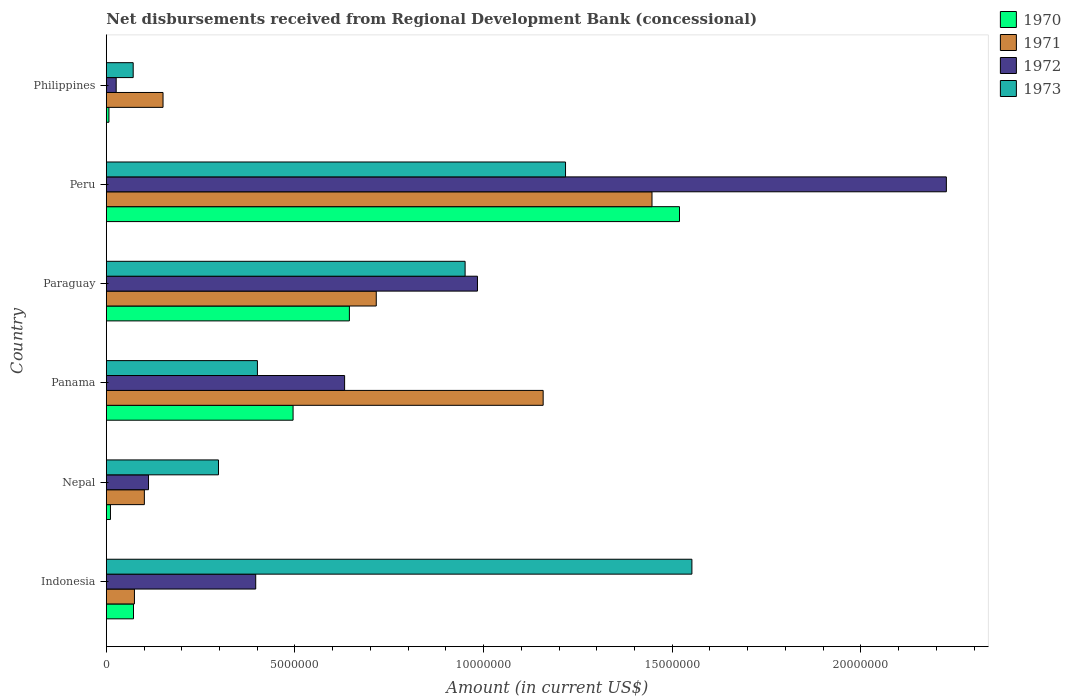How many different coloured bars are there?
Offer a very short reply. 4. Are the number of bars per tick equal to the number of legend labels?
Your answer should be very brief. Yes. Are the number of bars on each tick of the Y-axis equal?
Provide a short and direct response. Yes. In how many cases, is the number of bars for a given country not equal to the number of legend labels?
Make the answer very short. 0. What is the amount of disbursements received from Regional Development Bank in 1971 in Philippines?
Your answer should be compact. 1.50e+06. Across all countries, what is the maximum amount of disbursements received from Regional Development Bank in 1971?
Offer a very short reply. 1.45e+07. Across all countries, what is the minimum amount of disbursements received from Regional Development Bank in 1973?
Offer a terse response. 7.12e+05. What is the total amount of disbursements received from Regional Development Bank in 1973 in the graph?
Give a very brief answer. 4.49e+07. What is the difference between the amount of disbursements received from Regional Development Bank in 1971 in Paraguay and that in Peru?
Offer a terse response. -7.31e+06. What is the difference between the amount of disbursements received from Regional Development Bank in 1973 in Indonesia and the amount of disbursements received from Regional Development Bank in 1972 in Peru?
Your response must be concise. -6.74e+06. What is the average amount of disbursements received from Regional Development Bank in 1973 per country?
Your response must be concise. 7.48e+06. What is the difference between the amount of disbursements received from Regional Development Bank in 1971 and amount of disbursements received from Regional Development Bank in 1972 in Peru?
Keep it short and to the point. -7.80e+06. In how many countries, is the amount of disbursements received from Regional Development Bank in 1971 greater than 1000000 US$?
Give a very brief answer. 5. What is the ratio of the amount of disbursements received from Regional Development Bank in 1973 in Paraguay to that in Peru?
Your answer should be compact. 0.78. Is the amount of disbursements received from Regional Development Bank in 1971 in Indonesia less than that in Panama?
Give a very brief answer. Yes. Is the difference between the amount of disbursements received from Regional Development Bank in 1971 in Indonesia and Panama greater than the difference between the amount of disbursements received from Regional Development Bank in 1972 in Indonesia and Panama?
Your response must be concise. No. What is the difference between the highest and the second highest amount of disbursements received from Regional Development Bank in 1972?
Offer a very short reply. 1.24e+07. What is the difference between the highest and the lowest amount of disbursements received from Regional Development Bank in 1970?
Provide a short and direct response. 1.51e+07. In how many countries, is the amount of disbursements received from Regional Development Bank in 1973 greater than the average amount of disbursements received from Regional Development Bank in 1973 taken over all countries?
Offer a terse response. 3. Is it the case that in every country, the sum of the amount of disbursements received from Regional Development Bank in 1971 and amount of disbursements received from Regional Development Bank in 1972 is greater than the amount of disbursements received from Regional Development Bank in 1973?
Your response must be concise. No. How many bars are there?
Offer a terse response. 24. What is the difference between two consecutive major ticks on the X-axis?
Your answer should be very brief. 5.00e+06. Are the values on the major ticks of X-axis written in scientific E-notation?
Make the answer very short. No. How many legend labels are there?
Your answer should be very brief. 4. What is the title of the graph?
Ensure brevity in your answer.  Net disbursements received from Regional Development Bank (concessional). What is the label or title of the X-axis?
Provide a succinct answer. Amount (in current US$). What is the label or title of the Y-axis?
Your answer should be compact. Country. What is the Amount (in current US$) in 1970 in Indonesia?
Ensure brevity in your answer.  7.20e+05. What is the Amount (in current US$) in 1971 in Indonesia?
Ensure brevity in your answer.  7.45e+05. What is the Amount (in current US$) of 1972 in Indonesia?
Offer a terse response. 3.96e+06. What is the Amount (in current US$) in 1973 in Indonesia?
Provide a succinct answer. 1.55e+07. What is the Amount (in current US$) of 1970 in Nepal?
Provide a succinct answer. 1.09e+05. What is the Amount (in current US$) in 1971 in Nepal?
Your answer should be very brief. 1.01e+06. What is the Amount (in current US$) of 1972 in Nepal?
Make the answer very short. 1.12e+06. What is the Amount (in current US$) of 1973 in Nepal?
Offer a very short reply. 2.97e+06. What is the Amount (in current US$) of 1970 in Panama?
Ensure brevity in your answer.  4.95e+06. What is the Amount (in current US$) in 1971 in Panama?
Make the answer very short. 1.16e+07. What is the Amount (in current US$) in 1972 in Panama?
Your response must be concise. 6.32e+06. What is the Amount (in current US$) of 1973 in Panama?
Your answer should be compact. 4.00e+06. What is the Amount (in current US$) of 1970 in Paraguay?
Offer a very short reply. 6.44e+06. What is the Amount (in current US$) of 1971 in Paraguay?
Your answer should be very brief. 7.16e+06. What is the Amount (in current US$) in 1972 in Paraguay?
Give a very brief answer. 9.84e+06. What is the Amount (in current US$) of 1973 in Paraguay?
Your response must be concise. 9.51e+06. What is the Amount (in current US$) of 1970 in Peru?
Make the answer very short. 1.52e+07. What is the Amount (in current US$) in 1971 in Peru?
Your response must be concise. 1.45e+07. What is the Amount (in current US$) in 1972 in Peru?
Provide a short and direct response. 2.23e+07. What is the Amount (in current US$) of 1973 in Peru?
Make the answer very short. 1.22e+07. What is the Amount (in current US$) in 1970 in Philippines?
Ensure brevity in your answer.  6.90e+04. What is the Amount (in current US$) in 1971 in Philippines?
Your answer should be very brief. 1.50e+06. What is the Amount (in current US$) in 1972 in Philippines?
Your answer should be compact. 2.61e+05. What is the Amount (in current US$) in 1973 in Philippines?
Offer a terse response. 7.12e+05. Across all countries, what is the maximum Amount (in current US$) of 1970?
Give a very brief answer. 1.52e+07. Across all countries, what is the maximum Amount (in current US$) of 1971?
Your response must be concise. 1.45e+07. Across all countries, what is the maximum Amount (in current US$) in 1972?
Provide a succinct answer. 2.23e+07. Across all countries, what is the maximum Amount (in current US$) in 1973?
Give a very brief answer. 1.55e+07. Across all countries, what is the minimum Amount (in current US$) in 1970?
Offer a terse response. 6.90e+04. Across all countries, what is the minimum Amount (in current US$) of 1971?
Your response must be concise. 7.45e+05. Across all countries, what is the minimum Amount (in current US$) in 1972?
Keep it short and to the point. 2.61e+05. Across all countries, what is the minimum Amount (in current US$) of 1973?
Provide a succinct answer. 7.12e+05. What is the total Amount (in current US$) in 1970 in the graph?
Provide a succinct answer. 2.75e+07. What is the total Amount (in current US$) of 1971 in the graph?
Offer a terse response. 3.65e+07. What is the total Amount (in current US$) of 1972 in the graph?
Offer a terse response. 4.38e+07. What is the total Amount (in current US$) of 1973 in the graph?
Your answer should be very brief. 4.49e+07. What is the difference between the Amount (in current US$) in 1970 in Indonesia and that in Nepal?
Your response must be concise. 6.11e+05. What is the difference between the Amount (in current US$) in 1971 in Indonesia and that in Nepal?
Your response must be concise. -2.63e+05. What is the difference between the Amount (in current US$) of 1972 in Indonesia and that in Nepal?
Ensure brevity in your answer.  2.84e+06. What is the difference between the Amount (in current US$) in 1973 in Indonesia and that in Nepal?
Your answer should be very brief. 1.25e+07. What is the difference between the Amount (in current US$) of 1970 in Indonesia and that in Panama?
Ensure brevity in your answer.  -4.23e+06. What is the difference between the Amount (in current US$) in 1971 in Indonesia and that in Panama?
Your answer should be compact. -1.08e+07. What is the difference between the Amount (in current US$) in 1972 in Indonesia and that in Panama?
Give a very brief answer. -2.36e+06. What is the difference between the Amount (in current US$) in 1973 in Indonesia and that in Panama?
Make the answer very short. 1.15e+07. What is the difference between the Amount (in current US$) in 1970 in Indonesia and that in Paraguay?
Provide a short and direct response. -5.72e+06. What is the difference between the Amount (in current US$) of 1971 in Indonesia and that in Paraguay?
Provide a short and direct response. -6.41e+06. What is the difference between the Amount (in current US$) of 1972 in Indonesia and that in Paraguay?
Your answer should be very brief. -5.88e+06. What is the difference between the Amount (in current US$) of 1973 in Indonesia and that in Paraguay?
Give a very brief answer. 6.01e+06. What is the difference between the Amount (in current US$) in 1970 in Indonesia and that in Peru?
Make the answer very short. -1.45e+07. What is the difference between the Amount (in current US$) of 1971 in Indonesia and that in Peru?
Ensure brevity in your answer.  -1.37e+07. What is the difference between the Amount (in current US$) of 1972 in Indonesia and that in Peru?
Offer a terse response. -1.83e+07. What is the difference between the Amount (in current US$) of 1973 in Indonesia and that in Peru?
Provide a short and direct response. 3.35e+06. What is the difference between the Amount (in current US$) in 1970 in Indonesia and that in Philippines?
Your response must be concise. 6.51e+05. What is the difference between the Amount (in current US$) in 1971 in Indonesia and that in Philippines?
Ensure brevity in your answer.  -7.58e+05. What is the difference between the Amount (in current US$) in 1972 in Indonesia and that in Philippines?
Give a very brief answer. 3.70e+06. What is the difference between the Amount (in current US$) of 1973 in Indonesia and that in Philippines?
Offer a terse response. 1.48e+07. What is the difference between the Amount (in current US$) in 1970 in Nepal and that in Panama?
Your answer should be compact. -4.84e+06. What is the difference between the Amount (in current US$) in 1971 in Nepal and that in Panama?
Give a very brief answer. -1.06e+07. What is the difference between the Amount (in current US$) of 1972 in Nepal and that in Panama?
Your answer should be very brief. -5.20e+06. What is the difference between the Amount (in current US$) in 1973 in Nepal and that in Panama?
Make the answer very short. -1.03e+06. What is the difference between the Amount (in current US$) in 1970 in Nepal and that in Paraguay?
Provide a succinct answer. -6.33e+06. What is the difference between the Amount (in current US$) of 1971 in Nepal and that in Paraguay?
Your response must be concise. -6.15e+06. What is the difference between the Amount (in current US$) in 1972 in Nepal and that in Paraguay?
Your answer should be very brief. -8.72e+06. What is the difference between the Amount (in current US$) of 1973 in Nepal and that in Paraguay?
Your answer should be compact. -6.54e+06. What is the difference between the Amount (in current US$) in 1970 in Nepal and that in Peru?
Your answer should be compact. -1.51e+07. What is the difference between the Amount (in current US$) in 1971 in Nepal and that in Peru?
Ensure brevity in your answer.  -1.35e+07. What is the difference between the Amount (in current US$) in 1972 in Nepal and that in Peru?
Offer a very short reply. -2.11e+07. What is the difference between the Amount (in current US$) of 1973 in Nepal and that in Peru?
Provide a short and direct response. -9.20e+06. What is the difference between the Amount (in current US$) in 1971 in Nepal and that in Philippines?
Provide a succinct answer. -4.95e+05. What is the difference between the Amount (in current US$) of 1972 in Nepal and that in Philippines?
Your answer should be compact. 8.57e+05. What is the difference between the Amount (in current US$) of 1973 in Nepal and that in Philippines?
Ensure brevity in your answer.  2.26e+06. What is the difference between the Amount (in current US$) in 1970 in Panama and that in Paraguay?
Offer a terse response. -1.49e+06. What is the difference between the Amount (in current US$) of 1971 in Panama and that in Paraguay?
Your answer should be very brief. 4.42e+06. What is the difference between the Amount (in current US$) in 1972 in Panama and that in Paraguay?
Offer a terse response. -3.52e+06. What is the difference between the Amount (in current US$) in 1973 in Panama and that in Paraguay?
Provide a short and direct response. -5.50e+06. What is the difference between the Amount (in current US$) of 1970 in Panama and that in Peru?
Your response must be concise. -1.02e+07. What is the difference between the Amount (in current US$) of 1971 in Panama and that in Peru?
Offer a very short reply. -2.88e+06. What is the difference between the Amount (in current US$) in 1972 in Panama and that in Peru?
Ensure brevity in your answer.  -1.60e+07. What is the difference between the Amount (in current US$) of 1973 in Panama and that in Peru?
Make the answer very short. -8.17e+06. What is the difference between the Amount (in current US$) in 1970 in Panama and that in Philippines?
Offer a very short reply. 4.88e+06. What is the difference between the Amount (in current US$) in 1971 in Panama and that in Philippines?
Keep it short and to the point. 1.01e+07. What is the difference between the Amount (in current US$) in 1972 in Panama and that in Philippines?
Your answer should be compact. 6.06e+06. What is the difference between the Amount (in current US$) of 1973 in Panama and that in Philippines?
Your response must be concise. 3.29e+06. What is the difference between the Amount (in current US$) in 1970 in Paraguay and that in Peru?
Your response must be concise. -8.75e+06. What is the difference between the Amount (in current US$) in 1971 in Paraguay and that in Peru?
Provide a succinct answer. -7.31e+06. What is the difference between the Amount (in current US$) in 1972 in Paraguay and that in Peru?
Provide a succinct answer. -1.24e+07. What is the difference between the Amount (in current US$) in 1973 in Paraguay and that in Peru?
Keep it short and to the point. -2.66e+06. What is the difference between the Amount (in current US$) of 1970 in Paraguay and that in Philippines?
Your answer should be very brief. 6.37e+06. What is the difference between the Amount (in current US$) of 1971 in Paraguay and that in Philippines?
Offer a terse response. 5.65e+06. What is the difference between the Amount (in current US$) in 1972 in Paraguay and that in Philippines?
Your answer should be compact. 9.58e+06. What is the difference between the Amount (in current US$) in 1973 in Paraguay and that in Philippines?
Provide a succinct answer. 8.80e+06. What is the difference between the Amount (in current US$) of 1970 in Peru and that in Philippines?
Provide a succinct answer. 1.51e+07. What is the difference between the Amount (in current US$) of 1971 in Peru and that in Philippines?
Give a very brief answer. 1.30e+07. What is the difference between the Amount (in current US$) in 1972 in Peru and that in Philippines?
Your answer should be compact. 2.20e+07. What is the difference between the Amount (in current US$) of 1973 in Peru and that in Philippines?
Your answer should be compact. 1.15e+07. What is the difference between the Amount (in current US$) of 1970 in Indonesia and the Amount (in current US$) of 1971 in Nepal?
Ensure brevity in your answer.  -2.88e+05. What is the difference between the Amount (in current US$) of 1970 in Indonesia and the Amount (in current US$) of 1972 in Nepal?
Your answer should be compact. -3.98e+05. What is the difference between the Amount (in current US$) of 1970 in Indonesia and the Amount (in current US$) of 1973 in Nepal?
Give a very brief answer. -2.25e+06. What is the difference between the Amount (in current US$) in 1971 in Indonesia and the Amount (in current US$) in 1972 in Nepal?
Provide a short and direct response. -3.73e+05. What is the difference between the Amount (in current US$) of 1971 in Indonesia and the Amount (in current US$) of 1973 in Nepal?
Your response must be concise. -2.23e+06. What is the difference between the Amount (in current US$) of 1972 in Indonesia and the Amount (in current US$) of 1973 in Nepal?
Make the answer very short. 9.87e+05. What is the difference between the Amount (in current US$) in 1970 in Indonesia and the Amount (in current US$) in 1971 in Panama?
Your answer should be very brief. -1.09e+07. What is the difference between the Amount (in current US$) of 1970 in Indonesia and the Amount (in current US$) of 1972 in Panama?
Make the answer very short. -5.60e+06. What is the difference between the Amount (in current US$) of 1970 in Indonesia and the Amount (in current US$) of 1973 in Panama?
Offer a terse response. -3.28e+06. What is the difference between the Amount (in current US$) of 1971 in Indonesia and the Amount (in current US$) of 1972 in Panama?
Make the answer very short. -5.57e+06. What is the difference between the Amount (in current US$) of 1971 in Indonesia and the Amount (in current US$) of 1973 in Panama?
Your answer should be very brief. -3.26e+06. What is the difference between the Amount (in current US$) of 1972 in Indonesia and the Amount (in current US$) of 1973 in Panama?
Provide a short and direct response. -4.50e+04. What is the difference between the Amount (in current US$) in 1970 in Indonesia and the Amount (in current US$) in 1971 in Paraguay?
Offer a terse response. -6.44e+06. What is the difference between the Amount (in current US$) in 1970 in Indonesia and the Amount (in current US$) in 1972 in Paraguay?
Offer a terse response. -9.12e+06. What is the difference between the Amount (in current US$) in 1970 in Indonesia and the Amount (in current US$) in 1973 in Paraguay?
Your answer should be compact. -8.79e+06. What is the difference between the Amount (in current US$) in 1971 in Indonesia and the Amount (in current US$) in 1972 in Paraguay?
Keep it short and to the point. -9.09e+06. What is the difference between the Amount (in current US$) of 1971 in Indonesia and the Amount (in current US$) of 1973 in Paraguay?
Make the answer very short. -8.76e+06. What is the difference between the Amount (in current US$) in 1972 in Indonesia and the Amount (in current US$) in 1973 in Paraguay?
Make the answer very short. -5.55e+06. What is the difference between the Amount (in current US$) of 1970 in Indonesia and the Amount (in current US$) of 1971 in Peru?
Offer a very short reply. -1.37e+07. What is the difference between the Amount (in current US$) in 1970 in Indonesia and the Amount (in current US$) in 1972 in Peru?
Make the answer very short. -2.15e+07. What is the difference between the Amount (in current US$) of 1970 in Indonesia and the Amount (in current US$) of 1973 in Peru?
Your response must be concise. -1.15e+07. What is the difference between the Amount (in current US$) of 1971 in Indonesia and the Amount (in current US$) of 1972 in Peru?
Your answer should be very brief. -2.15e+07. What is the difference between the Amount (in current US$) of 1971 in Indonesia and the Amount (in current US$) of 1973 in Peru?
Your response must be concise. -1.14e+07. What is the difference between the Amount (in current US$) of 1972 in Indonesia and the Amount (in current US$) of 1973 in Peru?
Offer a very short reply. -8.21e+06. What is the difference between the Amount (in current US$) of 1970 in Indonesia and the Amount (in current US$) of 1971 in Philippines?
Keep it short and to the point. -7.83e+05. What is the difference between the Amount (in current US$) of 1970 in Indonesia and the Amount (in current US$) of 1972 in Philippines?
Offer a terse response. 4.59e+05. What is the difference between the Amount (in current US$) of 1970 in Indonesia and the Amount (in current US$) of 1973 in Philippines?
Your answer should be compact. 8000. What is the difference between the Amount (in current US$) of 1971 in Indonesia and the Amount (in current US$) of 1972 in Philippines?
Keep it short and to the point. 4.84e+05. What is the difference between the Amount (in current US$) in 1971 in Indonesia and the Amount (in current US$) in 1973 in Philippines?
Your answer should be compact. 3.30e+04. What is the difference between the Amount (in current US$) of 1972 in Indonesia and the Amount (in current US$) of 1973 in Philippines?
Provide a succinct answer. 3.25e+06. What is the difference between the Amount (in current US$) in 1970 in Nepal and the Amount (in current US$) in 1971 in Panama?
Make the answer very short. -1.15e+07. What is the difference between the Amount (in current US$) in 1970 in Nepal and the Amount (in current US$) in 1972 in Panama?
Ensure brevity in your answer.  -6.21e+06. What is the difference between the Amount (in current US$) of 1970 in Nepal and the Amount (in current US$) of 1973 in Panama?
Give a very brief answer. -3.90e+06. What is the difference between the Amount (in current US$) of 1971 in Nepal and the Amount (in current US$) of 1972 in Panama?
Keep it short and to the point. -5.31e+06. What is the difference between the Amount (in current US$) of 1971 in Nepal and the Amount (in current US$) of 1973 in Panama?
Provide a short and direct response. -3.00e+06. What is the difference between the Amount (in current US$) in 1972 in Nepal and the Amount (in current US$) in 1973 in Panama?
Offer a very short reply. -2.89e+06. What is the difference between the Amount (in current US$) in 1970 in Nepal and the Amount (in current US$) in 1971 in Paraguay?
Give a very brief answer. -7.05e+06. What is the difference between the Amount (in current US$) of 1970 in Nepal and the Amount (in current US$) of 1972 in Paraguay?
Ensure brevity in your answer.  -9.73e+06. What is the difference between the Amount (in current US$) of 1970 in Nepal and the Amount (in current US$) of 1973 in Paraguay?
Offer a terse response. -9.40e+06. What is the difference between the Amount (in current US$) in 1971 in Nepal and the Amount (in current US$) in 1972 in Paraguay?
Offer a very short reply. -8.83e+06. What is the difference between the Amount (in current US$) of 1971 in Nepal and the Amount (in current US$) of 1973 in Paraguay?
Your answer should be very brief. -8.50e+06. What is the difference between the Amount (in current US$) in 1972 in Nepal and the Amount (in current US$) in 1973 in Paraguay?
Ensure brevity in your answer.  -8.39e+06. What is the difference between the Amount (in current US$) of 1970 in Nepal and the Amount (in current US$) of 1971 in Peru?
Your answer should be compact. -1.44e+07. What is the difference between the Amount (in current US$) in 1970 in Nepal and the Amount (in current US$) in 1972 in Peru?
Offer a terse response. -2.22e+07. What is the difference between the Amount (in current US$) in 1970 in Nepal and the Amount (in current US$) in 1973 in Peru?
Ensure brevity in your answer.  -1.21e+07. What is the difference between the Amount (in current US$) of 1971 in Nepal and the Amount (in current US$) of 1972 in Peru?
Provide a short and direct response. -2.13e+07. What is the difference between the Amount (in current US$) in 1971 in Nepal and the Amount (in current US$) in 1973 in Peru?
Your response must be concise. -1.12e+07. What is the difference between the Amount (in current US$) of 1972 in Nepal and the Amount (in current US$) of 1973 in Peru?
Give a very brief answer. -1.11e+07. What is the difference between the Amount (in current US$) in 1970 in Nepal and the Amount (in current US$) in 1971 in Philippines?
Offer a terse response. -1.39e+06. What is the difference between the Amount (in current US$) of 1970 in Nepal and the Amount (in current US$) of 1972 in Philippines?
Make the answer very short. -1.52e+05. What is the difference between the Amount (in current US$) of 1970 in Nepal and the Amount (in current US$) of 1973 in Philippines?
Provide a short and direct response. -6.03e+05. What is the difference between the Amount (in current US$) of 1971 in Nepal and the Amount (in current US$) of 1972 in Philippines?
Offer a terse response. 7.47e+05. What is the difference between the Amount (in current US$) of 1971 in Nepal and the Amount (in current US$) of 1973 in Philippines?
Make the answer very short. 2.96e+05. What is the difference between the Amount (in current US$) of 1972 in Nepal and the Amount (in current US$) of 1973 in Philippines?
Give a very brief answer. 4.06e+05. What is the difference between the Amount (in current US$) in 1970 in Panama and the Amount (in current US$) in 1971 in Paraguay?
Offer a terse response. -2.20e+06. What is the difference between the Amount (in current US$) of 1970 in Panama and the Amount (in current US$) of 1972 in Paraguay?
Provide a succinct answer. -4.89e+06. What is the difference between the Amount (in current US$) in 1970 in Panama and the Amount (in current US$) in 1973 in Paraguay?
Provide a succinct answer. -4.56e+06. What is the difference between the Amount (in current US$) in 1971 in Panama and the Amount (in current US$) in 1972 in Paraguay?
Give a very brief answer. 1.74e+06. What is the difference between the Amount (in current US$) of 1971 in Panama and the Amount (in current US$) of 1973 in Paraguay?
Give a very brief answer. 2.07e+06. What is the difference between the Amount (in current US$) of 1972 in Panama and the Amount (in current US$) of 1973 in Paraguay?
Give a very brief answer. -3.19e+06. What is the difference between the Amount (in current US$) in 1970 in Panama and the Amount (in current US$) in 1971 in Peru?
Keep it short and to the point. -9.51e+06. What is the difference between the Amount (in current US$) of 1970 in Panama and the Amount (in current US$) of 1972 in Peru?
Offer a very short reply. -1.73e+07. What is the difference between the Amount (in current US$) of 1970 in Panama and the Amount (in current US$) of 1973 in Peru?
Provide a short and direct response. -7.22e+06. What is the difference between the Amount (in current US$) in 1971 in Panama and the Amount (in current US$) in 1972 in Peru?
Make the answer very short. -1.07e+07. What is the difference between the Amount (in current US$) of 1971 in Panama and the Amount (in current US$) of 1973 in Peru?
Your answer should be very brief. -5.93e+05. What is the difference between the Amount (in current US$) in 1972 in Panama and the Amount (in current US$) in 1973 in Peru?
Offer a very short reply. -5.86e+06. What is the difference between the Amount (in current US$) of 1970 in Panama and the Amount (in current US$) of 1971 in Philippines?
Provide a succinct answer. 3.45e+06. What is the difference between the Amount (in current US$) in 1970 in Panama and the Amount (in current US$) in 1972 in Philippines?
Your answer should be very brief. 4.69e+06. What is the difference between the Amount (in current US$) of 1970 in Panama and the Amount (in current US$) of 1973 in Philippines?
Give a very brief answer. 4.24e+06. What is the difference between the Amount (in current US$) of 1971 in Panama and the Amount (in current US$) of 1972 in Philippines?
Your answer should be very brief. 1.13e+07. What is the difference between the Amount (in current US$) in 1971 in Panama and the Amount (in current US$) in 1973 in Philippines?
Ensure brevity in your answer.  1.09e+07. What is the difference between the Amount (in current US$) in 1972 in Panama and the Amount (in current US$) in 1973 in Philippines?
Offer a very short reply. 5.60e+06. What is the difference between the Amount (in current US$) of 1970 in Paraguay and the Amount (in current US$) of 1971 in Peru?
Offer a very short reply. -8.02e+06. What is the difference between the Amount (in current US$) in 1970 in Paraguay and the Amount (in current US$) in 1972 in Peru?
Offer a very short reply. -1.58e+07. What is the difference between the Amount (in current US$) in 1970 in Paraguay and the Amount (in current US$) in 1973 in Peru?
Your response must be concise. -5.73e+06. What is the difference between the Amount (in current US$) in 1971 in Paraguay and the Amount (in current US$) in 1972 in Peru?
Make the answer very short. -1.51e+07. What is the difference between the Amount (in current US$) of 1971 in Paraguay and the Amount (in current US$) of 1973 in Peru?
Your answer should be very brief. -5.02e+06. What is the difference between the Amount (in current US$) in 1972 in Paraguay and the Amount (in current US$) in 1973 in Peru?
Offer a very short reply. -2.33e+06. What is the difference between the Amount (in current US$) in 1970 in Paraguay and the Amount (in current US$) in 1971 in Philippines?
Ensure brevity in your answer.  4.94e+06. What is the difference between the Amount (in current US$) of 1970 in Paraguay and the Amount (in current US$) of 1972 in Philippines?
Give a very brief answer. 6.18e+06. What is the difference between the Amount (in current US$) of 1970 in Paraguay and the Amount (in current US$) of 1973 in Philippines?
Your answer should be very brief. 5.73e+06. What is the difference between the Amount (in current US$) in 1971 in Paraguay and the Amount (in current US$) in 1972 in Philippines?
Offer a terse response. 6.89e+06. What is the difference between the Amount (in current US$) in 1971 in Paraguay and the Amount (in current US$) in 1973 in Philippines?
Your response must be concise. 6.44e+06. What is the difference between the Amount (in current US$) of 1972 in Paraguay and the Amount (in current US$) of 1973 in Philippines?
Offer a very short reply. 9.13e+06. What is the difference between the Amount (in current US$) of 1970 in Peru and the Amount (in current US$) of 1971 in Philippines?
Your answer should be very brief. 1.37e+07. What is the difference between the Amount (in current US$) in 1970 in Peru and the Amount (in current US$) in 1972 in Philippines?
Your answer should be very brief. 1.49e+07. What is the difference between the Amount (in current US$) of 1970 in Peru and the Amount (in current US$) of 1973 in Philippines?
Your answer should be very brief. 1.45e+07. What is the difference between the Amount (in current US$) in 1971 in Peru and the Amount (in current US$) in 1972 in Philippines?
Your answer should be compact. 1.42e+07. What is the difference between the Amount (in current US$) of 1971 in Peru and the Amount (in current US$) of 1973 in Philippines?
Offer a very short reply. 1.38e+07. What is the difference between the Amount (in current US$) in 1972 in Peru and the Amount (in current US$) in 1973 in Philippines?
Your answer should be very brief. 2.16e+07. What is the average Amount (in current US$) of 1970 per country?
Your response must be concise. 4.58e+06. What is the average Amount (in current US$) in 1971 per country?
Ensure brevity in your answer.  6.08e+06. What is the average Amount (in current US$) of 1972 per country?
Ensure brevity in your answer.  7.29e+06. What is the average Amount (in current US$) in 1973 per country?
Your answer should be compact. 7.48e+06. What is the difference between the Amount (in current US$) of 1970 and Amount (in current US$) of 1971 in Indonesia?
Your response must be concise. -2.50e+04. What is the difference between the Amount (in current US$) in 1970 and Amount (in current US$) in 1972 in Indonesia?
Give a very brief answer. -3.24e+06. What is the difference between the Amount (in current US$) of 1970 and Amount (in current US$) of 1973 in Indonesia?
Keep it short and to the point. -1.48e+07. What is the difference between the Amount (in current US$) in 1971 and Amount (in current US$) in 1972 in Indonesia?
Your response must be concise. -3.22e+06. What is the difference between the Amount (in current US$) in 1971 and Amount (in current US$) in 1973 in Indonesia?
Provide a succinct answer. -1.48e+07. What is the difference between the Amount (in current US$) in 1972 and Amount (in current US$) in 1973 in Indonesia?
Make the answer very short. -1.16e+07. What is the difference between the Amount (in current US$) of 1970 and Amount (in current US$) of 1971 in Nepal?
Your answer should be very brief. -8.99e+05. What is the difference between the Amount (in current US$) in 1970 and Amount (in current US$) in 1972 in Nepal?
Ensure brevity in your answer.  -1.01e+06. What is the difference between the Amount (in current US$) in 1970 and Amount (in current US$) in 1973 in Nepal?
Provide a short and direct response. -2.86e+06. What is the difference between the Amount (in current US$) of 1971 and Amount (in current US$) of 1973 in Nepal?
Your answer should be very brief. -1.96e+06. What is the difference between the Amount (in current US$) in 1972 and Amount (in current US$) in 1973 in Nepal?
Your answer should be compact. -1.86e+06. What is the difference between the Amount (in current US$) in 1970 and Amount (in current US$) in 1971 in Panama?
Provide a short and direct response. -6.63e+06. What is the difference between the Amount (in current US$) in 1970 and Amount (in current US$) in 1972 in Panama?
Your answer should be very brief. -1.37e+06. What is the difference between the Amount (in current US$) in 1970 and Amount (in current US$) in 1973 in Panama?
Provide a succinct answer. 9.45e+05. What is the difference between the Amount (in current US$) of 1971 and Amount (in current US$) of 1972 in Panama?
Make the answer very short. 5.26e+06. What is the difference between the Amount (in current US$) of 1971 and Amount (in current US$) of 1973 in Panama?
Provide a succinct answer. 7.57e+06. What is the difference between the Amount (in current US$) in 1972 and Amount (in current US$) in 1973 in Panama?
Give a very brief answer. 2.31e+06. What is the difference between the Amount (in current US$) in 1970 and Amount (in current US$) in 1971 in Paraguay?
Your response must be concise. -7.12e+05. What is the difference between the Amount (in current US$) of 1970 and Amount (in current US$) of 1972 in Paraguay?
Offer a terse response. -3.40e+06. What is the difference between the Amount (in current US$) of 1970 and Amount (in current US$) of 1973 in Paraguay?
Provide a short and direct response. -3.07e+06. What is the difference between the Amount (in current US$) in 1971 and Amount (in current US$) in 1972 in Paraguay?
Give a very brief answer. -2.68e+06. What is the difference between the Amount (in current US$) of 1971 and Amount (in current US$) of 1973 in Paraguay?
Your response must be concise. -2.36e+06. What is the difference between the Amount (in current US$) in 1972 and Amount (in current US$) in 1973 in Paraguay?
Provide a succinct answer. 3.28e+05. What is the difference between the Amount (in current US$) in 1970 and Amount (in current US$) in 1971 in Peru?
Offer a terse response. 7.29e+05. What is the difference between the Amount (in current US$) of 1970 and Amount (in current US$) of 1972 in Peru?
Your answer should be compact. -7.07e+06. What is the difference between the Amount (in current US$) in 1970 and Amount (in current US$) in 1973 in Peru?
Provide a succinct answer. 3.02e+06. What is the difference between the Amount (in current US$) of 1971 and Amount (in current US$) of 1972 in Peru?
Offer a terse response. -7.80e+06. What is the difference between the Amount (in current US$) in 1971 and Amount (in current US$) in 1973 in Peru?
Offer a terse response. 2.29e+06. What is the difference between the Amount (in current US$) of 1972 and Amount (in current US$) of 1973 in Peru?
Give a very brief answer. 1.01e+07. What is the difference between the Amount (in current US$) in 1970 and Amount (in current US$) in 1971 in Philippines?
Offer a terse response. -1.43e+06. What is the difference between the Amount (in current US$) of 1970 and Amount (in current US$) of 1972 in Philippines?
Your answer should be compact. -1.92e+05. What is the difference between the Amount (in current US$) in 1970 and Amount (in current US$) in 1973 in Philippines?
Provide a succinct answer. -6.43e+05. What is the difference between the Amount (in current US$) of 1971 and Amount (in current US$) of 1972 in Philippines?
Keep it short and to the point. 1.24e+06. What is the difference between the Amount (in current US$) in 1971 and Amount (in current US$) in 1973 in Philippines?
Make the answer very short. 7.91e+05. What is the difference between the Amount (in current US$) in 1972 and Amount (in current US$) in 1973 in Philippines?
Keep it short and to the point. -4.51e+05. What is the ratio of the Amount (in current US$) in 1970 in Indonesia to that in Nepal?
Your response must be concise. 6.61. What is the ratio of the Amount (in current US$) in 1971 in Indonesia to that in Nepal?
Ensure brevity in your answer.  0.74. What is the ratio of the Amount (in current US$) in 1972 in Indonesia to that in Nepal?
Your answer should be compact. 3.54. What is the ratio of the Amount (in current US$) of 1973 in Indonesia to that in Nepal?
Your response must be concise. 5.22. What is the ratio of the Amount (in current US$) in 1970 in Indonesia to that in Panama?
Keep it short and to the point. 0.15. What is the ratio of the Amount (in current US$) in 1971 in Indonesia to that in Panama?
Give a very brief answer. 0.06. What is the ratio of the Amount (in current US$) in 1972 in Indonesia to that in Panama?
Offer a terse response. 0.63. What is the ratio of the Amount (in current US$) in 1973 in Indonesia to that in Panama?
Give a very brief answer. 3.88. What is the ratio of the Amount (in current US$) of 1970 in Indonesia to that in Paraguay?
Your answer should be very brief. 0.11. What is the ratio of the Amount (in current US$) of 1971 in Indonesia to that in Paraguay?
Keep it short and to the point. 0.1. What is the ratio of the Amount (in current US$) in 1972 in Indonesia to that in Paraguay?
Offer a terse response. 0.4. What is the ratio of the Amount (in current US$) of 1973 in Indonesia to that in Paraguay?
Ensure brevity in your answer.  1.63. What is the ratio of the Amount (in current US$) in 1970 in Indonesia to that in Peru?
Give a very brief answer. 0.05. What is the ratio of the Amount (in current US$) in 1971 in Indonesia to that in Peru?
Provide a succinct answer. 0.05. What is the ratio of the Amount (in current US$) of 1972 in Indonesia to that in Peru?
Ensure brevity in your answer.  0.18. What is the ratio of the Amount (in current US$) in 1973 in Indonesia to that in Peru?
Your answer should be very brief. 1.28. What is the ratio of the Amount (in current US$) of 1970 in Indonesia to that in Philippines?
Your response must be concise. 10.43. What is the ratio of the Amount (in current US$) in 1971 in Indonesia to that in Philippines?
Keep it short and to the point. 0.5. What is the ratio of the Amount (in current US$) of 1972 in Indonesia to that in Philippines?
Ensure brevity in your answer.  15.17. What is the ratio of the Amount (in current US$) of 1973 in Indonesia to that in Philippines?
Your answer should be very brief. 21.8. What is the ratio of the Amount (in current US$) of 1970 in Nepal to that in Panama?
Provide a succinct answer. 0.02. What is the ratio of the Amount (in current US$) of 1971 in Nepal to that in Panama?
Ensure brevity in your answer.  0.09. What is the ratio of the Amount (in current US$) of 1972 in Nepal to that in Panama?
Offer a terse response. 0.18. What is the ratio of the Amount (in current US$) of 1973 in Nepal to that in Panama?
Your response must be concise. 0.74. What is the ratio of the Amount (in current US$) in 1970 in Nepal to that in Paraguay?
Ensure brevity in your answer.  0.02. What is the ratio of the Amount (in current US$) in 1971 in Nepal to that in Paraguay?
Keep it short and to the point. 0.14. What is the ratio of the Amount (in current US$) of 1972 in Nepal to that in Paraguay?
Make the answer very short. 0.11. What is the ratio of the Amount (in current US$) of 1973 in Nepal to that in Paraguay?
Ensure brevity in your answer.  0.31. What is the ratio of the Amount (in current US$) of 1970 in Nepal to that in Peru?
Keep it short and to the point. 0.01. What is the ratio of the Amount (in current US$) of 1971 in Nepal to that in Peru?
Keep it short and to the point. 0.07. What is the ratio of the Amount (in current US$) of 1972 in Nepal to that in Peru?
Your answer should be very brief. 0.05. What is the ratio of the Amount (in current US$) of 1973 in Nepal to that in Peru?
Ensure brevity in your answer.  0.24. What is the ratio of the Amount (in current US$) of 1970 in Nepal to that in Philippines?
Give a very brief answer. 1.58. What is the ratio of the Amount (in current US$) in 1971 in Nepal to that in Philippines?
Provide a succinct answer. 0.67. What is the ratio of the Amount (in current US$) of 1972 in Nepal to that in Philippines?
Offer a terse response. 4.28. What is the ratio of the Amount (in current US$) of 1973 in Nepal to that in Philippines?
Offer a very short reply. 4.18. What is the ratio of the Amount (in current US$) of 1970 in Panama to that in Paraguay?
Provide a succinct answer. 0.77. What is the ratio of the Amount (in current US$) of 1971 in Panama to that in Paraguay?
Provide a short and direct response. 1.62. What is the ratio of the Amount (in current US$) in 1972 in Panama to that in Paraguay?
Your response must be concise. 0.64. What is the ratio of the Amount (in current US$) of 1973 in Panama to that in Paraguay?
Your answer should be very brief. 0.42. What is the ratio of the Amount (in current US$) of 1970 in Panama to that in Peru?
Provide a short and direct response. 0.33. What is the ratio of the Amount (in current US$) in 1971 in Panama to that in Peru?
Offer a very short reply. 0.8. What is the ratio of the Amount (in current US$) of 1972 in Panama to that in Peru?
Your answer should be very brief. 0.28. What is the ratio of the Amount (in current US$) in 1973 in Panama to that in Peru?
Make the answer very short. 0.33. What is the ratio of the Amount (in current US$) in 1970 in Panama to that in Philippines?
Ensure brevity in your answer.  71.74. What is the ratio of the Amount (in current US$) in 1971 in Panama to that in Philippines?
Keep it short and to the point. 7.7. What is the ratio of the Amount (in current US$) of 1972 in Panama to that in Philippines?
Provide a short and direct response. 24.2. What is the ratio of the Amount (in current US$) of 1973 in Panama to that in Philippines?
Your answer should be compact. 5.62. What is the ratio of the Amount (in current US$) in 1970 in Paraguay to that in Peru?
Give a very brief answer. 0.42. What is the ratio of the Amount (in current US$) of 1971 in Paraguay to that in Peru?
Offer a terse response. 0.49. What is the ratio of the Amount (in current US$) in 1972 in Paraguay to that in Peru?
Offer a very short reply. 0.44. What is the ratio of the Amount (in current US$) of 1973 in Paraguay to that in Peru?
Your answer should be compact. 0.78. What is the ratio of the Amount (in current US$) in 1970 in Paraguay to that in Philippines?
Keep it short and to the point. 93.38. What is the ratio of the Amount (in current US$) of 1971 in Paraguay to that in Philippines?
Offer a very short reply. 4.76. What is the ratio of the Amount (in current US$) of 1972 in Paraguay to that in Philippines?
Keep it short and to the point. 37.69. What is the ratio of the Amount (in current US$) of 1973 in Paraguay to that in Philippines?
Your answer should be compact. 13.36. What is the ratio of the Amount (in current US$) of 1970 in Peru to that in Philippines?
Your answer should be very brief. 220.19. What is the ratio of the Amount (in current US$) in 1971 in Peru to that in Philippines?
Provide a short and direct response. 9.62. What is the ratio of the Amount (in current US$) in 1972 in Peru to that in Philippines?
Your response must be concise. 85.31. What is the ratio of the Amount (in current US$) in 1973 in Peru to that in Philippines?
Your answer should be compact. 17.1. What is the difference between the highest and the second highest Amount (in current US$) of 1970?
Your response must be concise. 8.75e+06. What is the difference between the highest and the second highest Amount (in current US$) in 1971?
Keep it short and to the point. 2.88e+06. What is the difference between the highest and the second highest Amount (in current US$) in 1972?
Your answer should be compact. 1.24e+07. What is the difference between the highest and the second highest Amount (in current US$) of 1973?
Your answer should be very brief. 3.35e+06. What is the difference between the highest and the lowest Amount (in current US$) in 1970?
Give a very brief answer. 1.51e+07. What is the difference between the highest and the lowest Amount (in current US$) in 1971?
Your answer should be compact. 1.37e+07. What is the difference between the highest and the lowest Amount (in current US$) of 1972?
Provide a short and direct response. 2.20e+07. What is the difference between the highest and the lowest Amount (in current US$) of 1973?
Offer a terse response. 1.48e+07. 